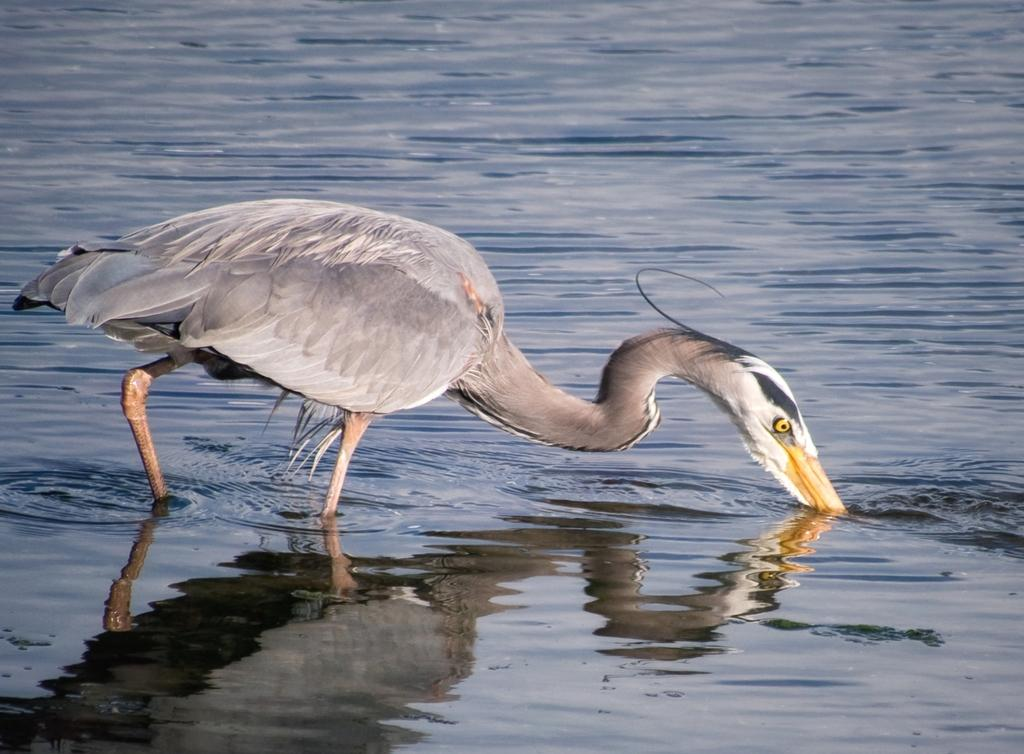What is the main subject of the image? The main subject of the image is a crane. Where is the crane located in the image? The crane is in the water. What are some features of the crane? The crane has an eye, a beak, and feathers. What type of care does the governor provide for the crane in the image? There is no governor present in the image, and therefore no care can be provided by a governor. 